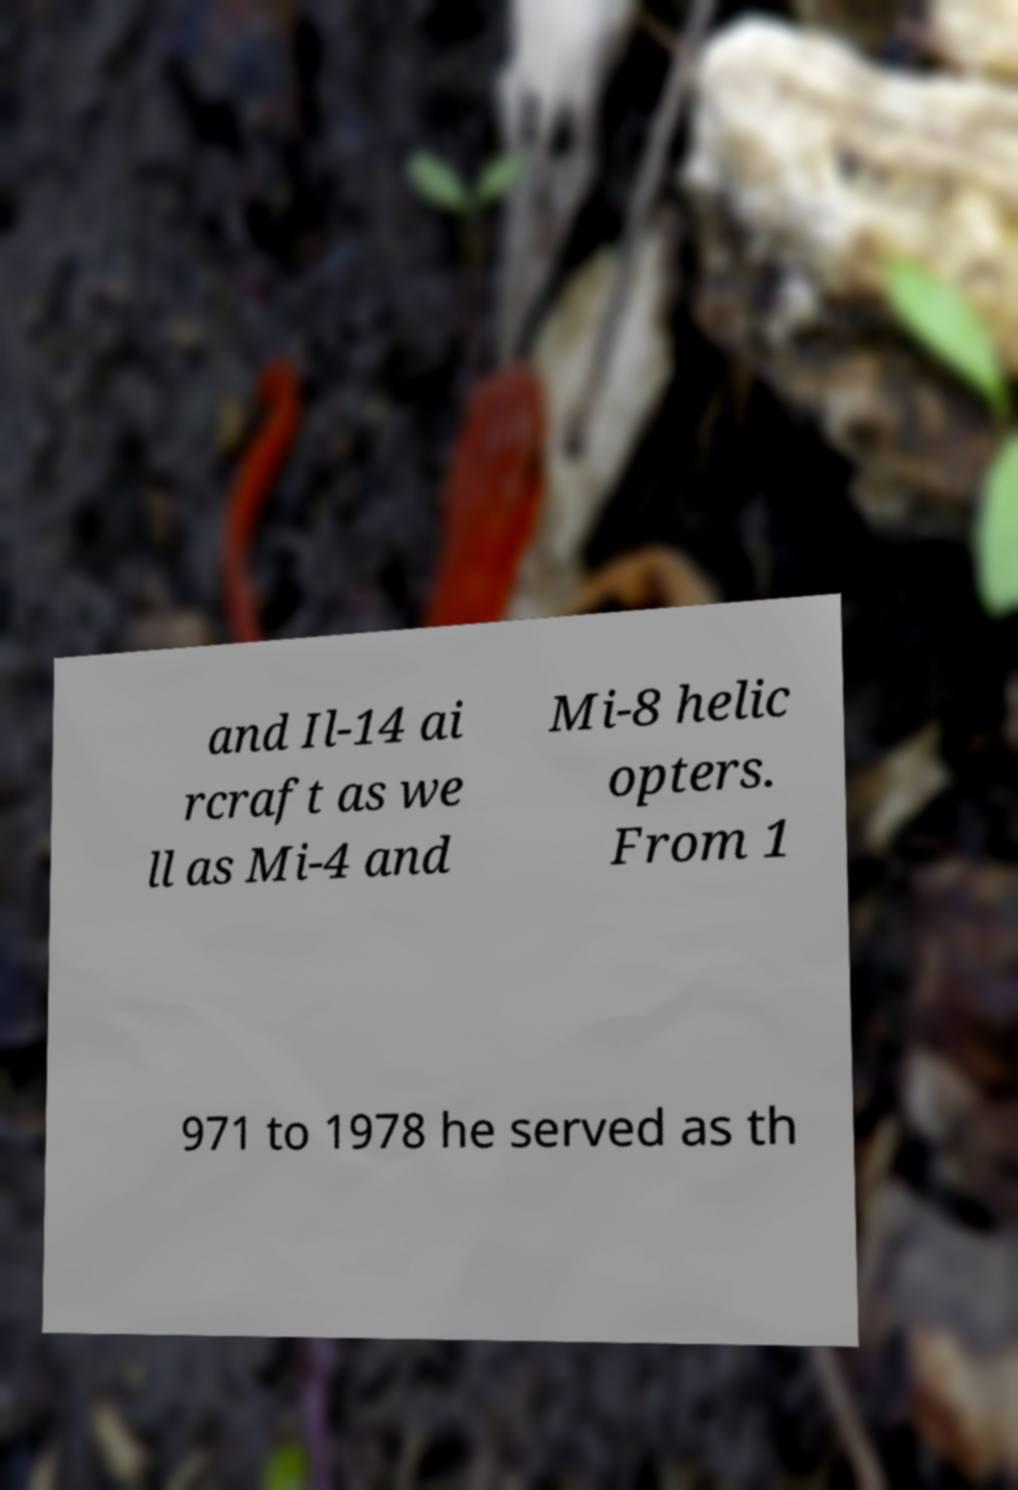Can you read and provide the text displayed in the image?This photo seems to have some interesting text. Can you extract and type it out for me? and Il-14 ai rcraft as we ll as Mi-4 and Mi-8 helic opters. From 1 971 to 1978 he served as th 